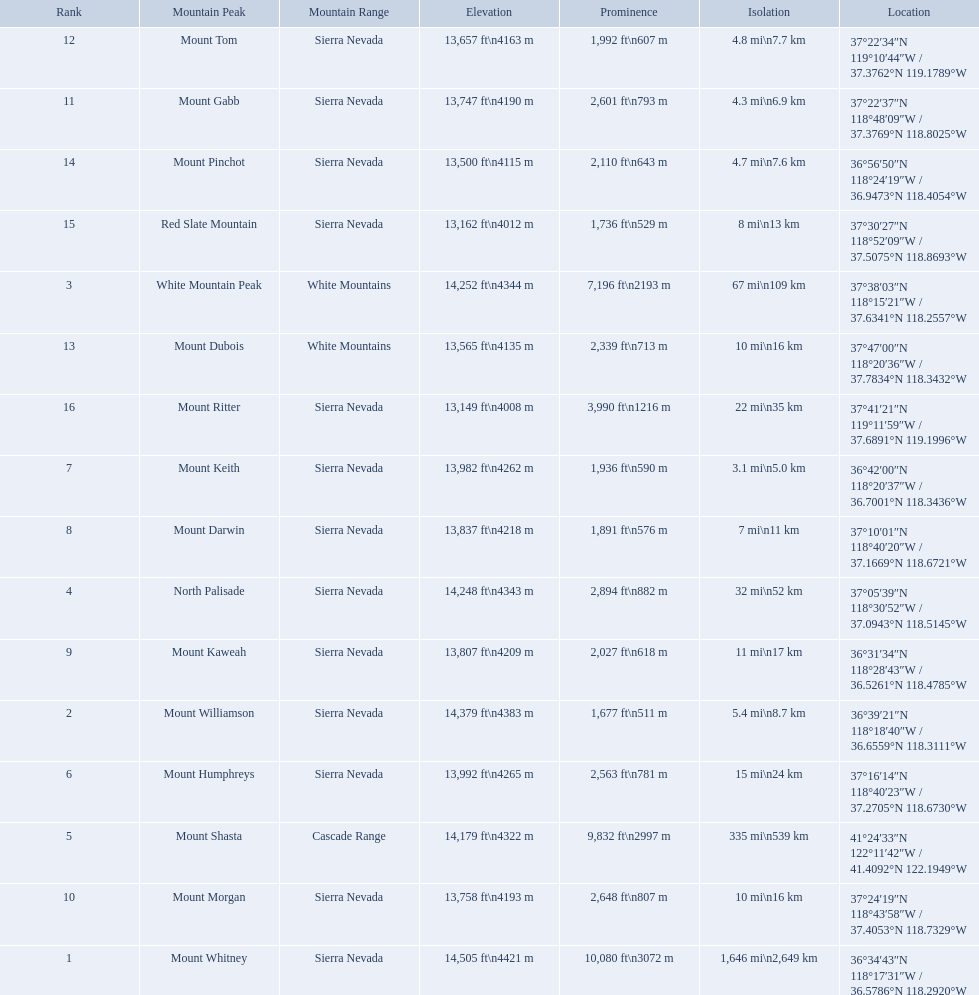What mountain peak is listed for the sierra nevada mountain range? Mount Whitney. What mountain peak has an elevation of 14,379ft? Mount Williamson. Which mountain is listed for the cascade range? Mount Shasta. 